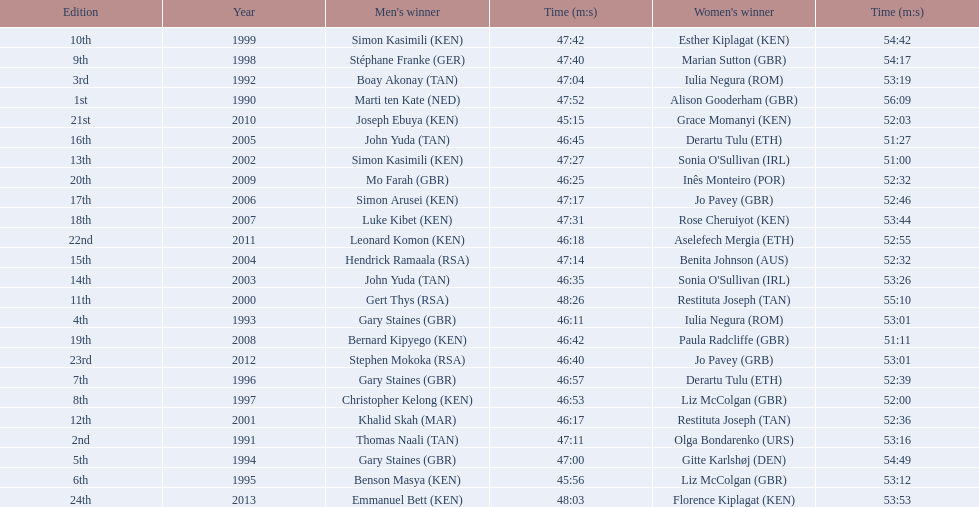Which of the runner in the great south run were women? Alison Gooderham (GBR), Olga Bondarenko (URS), Iulia Negura (ROM), Iulia Negura (ROM), Gitte Karlshøj (DEN), Liz McColgan (GBR), Derartu Tulu (ETH), Liz McColgan (GBR), Marian Sutton (GBR), Esther Kiplagat (KEN), Restituta Joseph (TAN), Restituta Joseph (TAN), Sonia O'Sullivan (IRL), Sonia O'Sullivan (IRL), Benita Johnson (AUS), Derartu Tulu (ETH), Jo Pavey (GBR), Rose Cheruiyot (KEN), Paula Radcliffe (GBR), Inês Monteiro (POR), Grace Momanyi (KEN), Aselefech Mergia (ETH), Jo Pavey (GRB), Florence Kiplagat (KEN). Of those women, which ones had a time of at least 53 minutes? Alison Gooderham (GBR), Olga Bondarenko (URS), Iulia Negura (ROM), Iulia Negura (ROM), Gitte Karlshøj (DEN), Liz McColgan (GBR), Marian Sutton (GBR), Esther Kiplagat (KEN), Restituta Joseph (TAN), Sonia O'Sullivan (IRL), Rose Cheruiyot (KEN), Jo Pavey (GRB), Florence Kiplagat (KEN). Between those women, which ones did not go over 53 minutes? Olga Bondarenko (URS), Iulia Negura (ROM), Iulia Negura (ROM), Liz McColgan (GBR), Sonia O'Sullivan (IRL), Rose Cheruiyot (KEN), Jo Pavey (GRB), Florence Kiplagat (KEN). Of those 8, what were the three slowest times? Sonia O'Sullivan (IRL), Rose Cheruiyot (KEN), Florence Kiplagat (KEN). Between only those 3 women, which runner had the fastest time? Sonia O'Sullivan (IRL). What was this women's time? 53:26. 